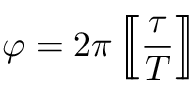Convert formula to latex. <formula><loc_0><loc_0><loc_500><loc_500>\varphi = 2 \pi \left [ \, \left [ { \frac { \tau } { T } } \right ] \, \right ]</formula> 